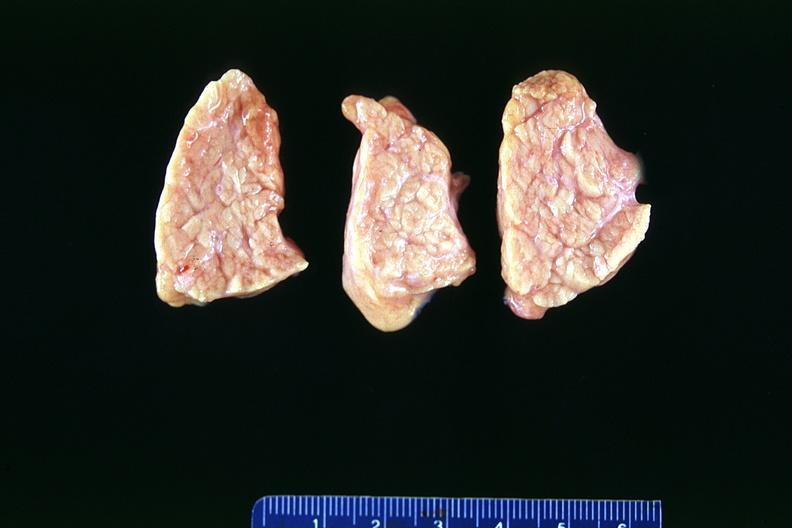does this image show normal pancreas?
Answer the question using a single word or phrase. Yes 